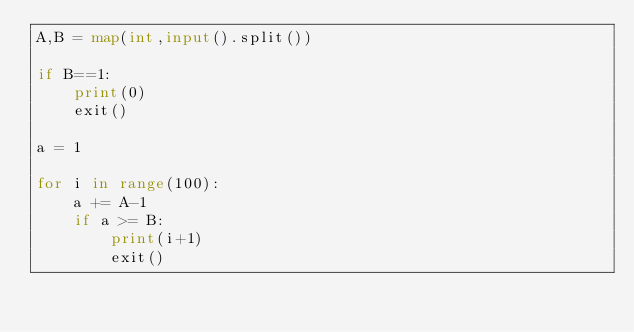<code> <loc_0><loc_0><loc_500><loc_500><_Python_>A,B = map(int,input().split())

if B==1:
    print(0)
    exit()

a = 1

for i in range(100):
    a += A-1
    if a >= B:
        print(i+1)
        exit()</code> 